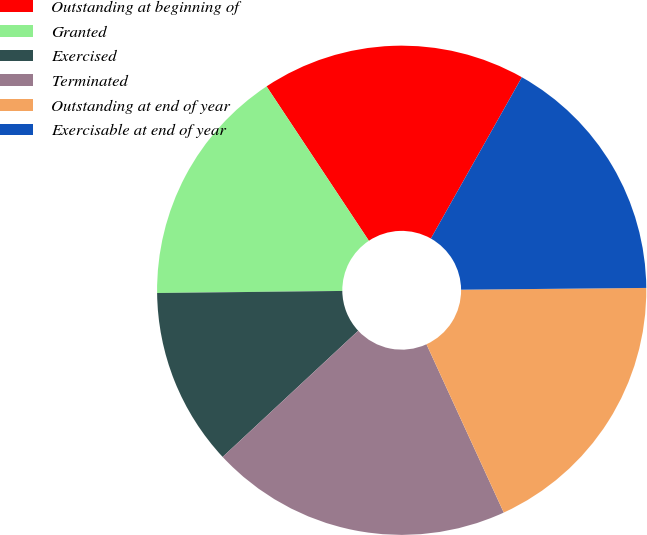Convert chart. <chart><loc_0><loc_0><loc_500><loc_500><pie_chart><fcel>Outstanding at beginning of<fcel>Granted<fcel>Exercised<fcel>Terminated<fcel>Outstanding at end of year<fcel>Exercisable at end of year<nl><fcel>17.49%<fcel>15.86%<fcel>11.75%<fcel>19.92%<fcel>18.3%<fcel>16.67%<nl></chart> 